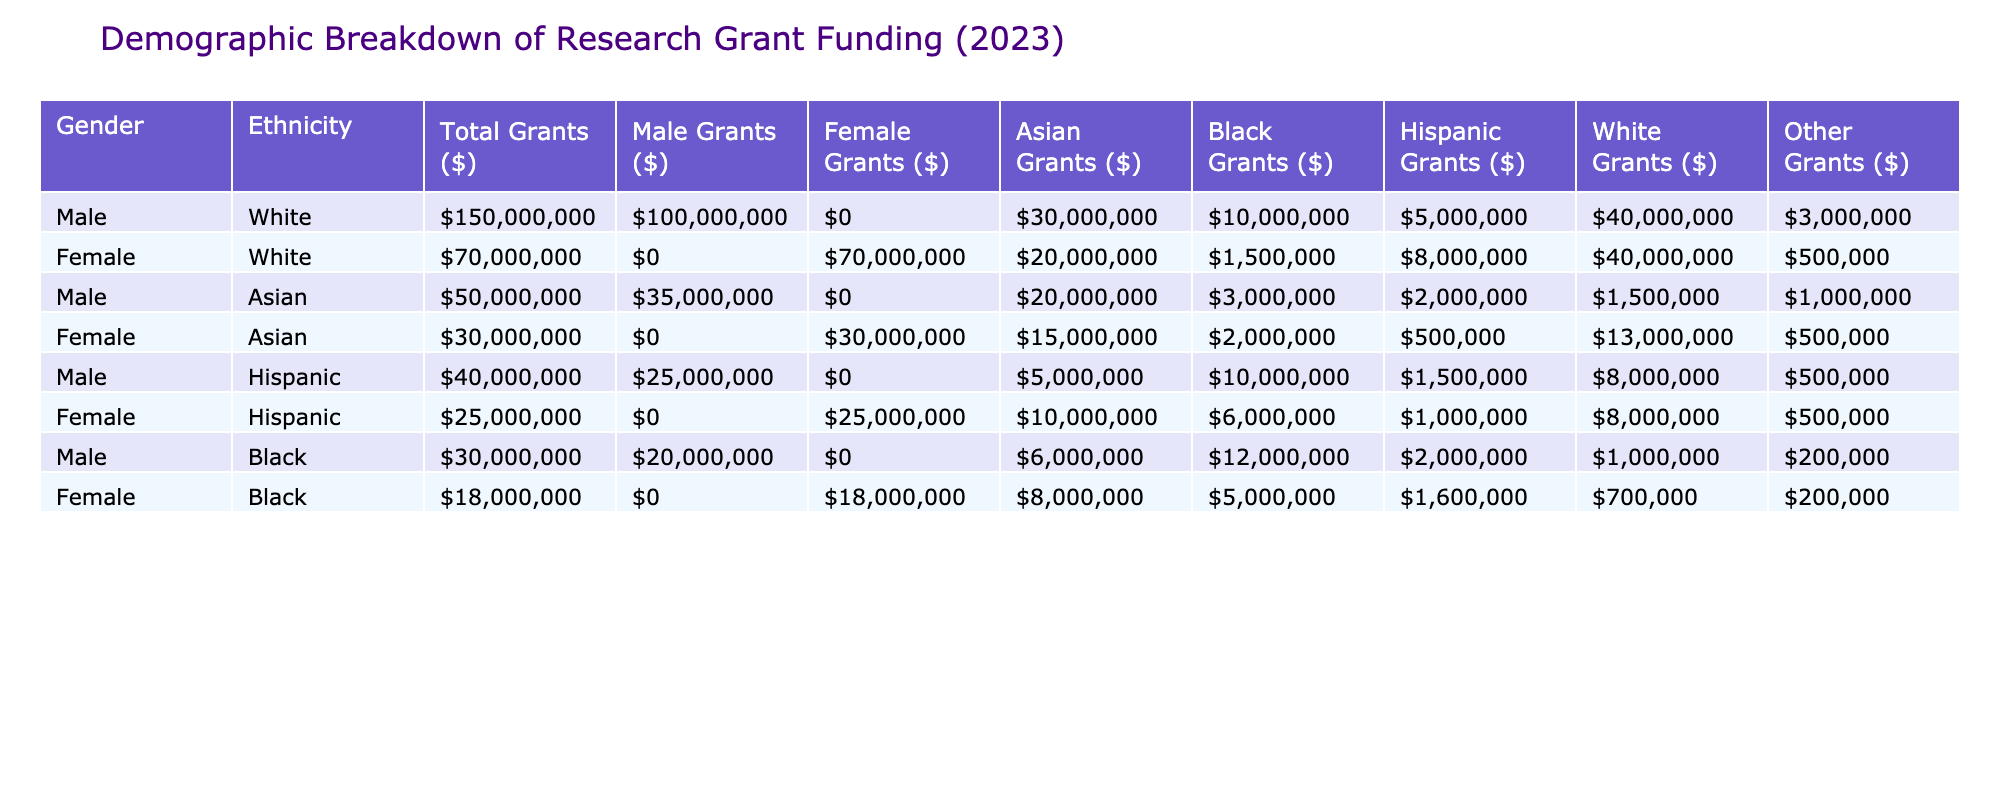What is the total amount of grants awarded to Black females? The table shows the total grants awarded to Black females, which is $18,000,000. This is indicated in the "Female, Black" row under the "Total Grants ($)" column.
Answer: $18,000,000 How many grants were awarded to White males compared to White females? The total grants awarded to White males is $150,000,000 while White females received $70,000,000. The difference between them is $150,000,000 - $70,000,000 = $80,000,000.
Answer: $80,000,000 Did Asian females receive more funding than Black females? Asian females received $30,000,000 while Black females received $18,000,000. Since $30,000,000 is greater than $18,000,000, the assertion is true.
Answer: Yes What is the total funding awarded to male individuals across all ethnicities? To find this, sum all the grants awarded to males: $100,000,000 (White) + $35,000,000 (Asian) + $25,000,000 (Hispanic) + $20,000,000 (Black) = $280,000,000.
Answer: $280,000,000 How many total grants were awarded to Black individuals (both males and females)? For Black individuals, the funding is: Black males received $30,000,000 and Black females received $18,000,000. To find the total, $30,000,000 + $18,000,000 = $48,000,000.
Answer: $48,000,000 What percentage of total grants did Hispanic females receive compared to total funding? Hispanic females received $25,000,000 out of a total funding of $650,000,000 (sum of all grants). The percentage is calculated as ($25,000,000 / $650,000,000) * 100 = 3.85%.
Answer: 3.85% Which gender received more funding in the Asian ethnicity group? For the Asian ethnicity, males received $35,000,000 while females received $30,000,000. Since $35,000,000 is greater than $30,000,000, males received more funding.
Answer: Males What is the average amount of grants awarded to each ethnicity category for males? The total grants for males across all ethnicities sum up to: $100,000,000 (White) + $35,000,000 (Asian) + $25,000,000 (Hispanic) + $30,000,000 (Black) = $290,000,000. There are 4 ethnicities, so the average is $290,000,000 / 4 = $72,500,000.
Answer: $72,500,000 